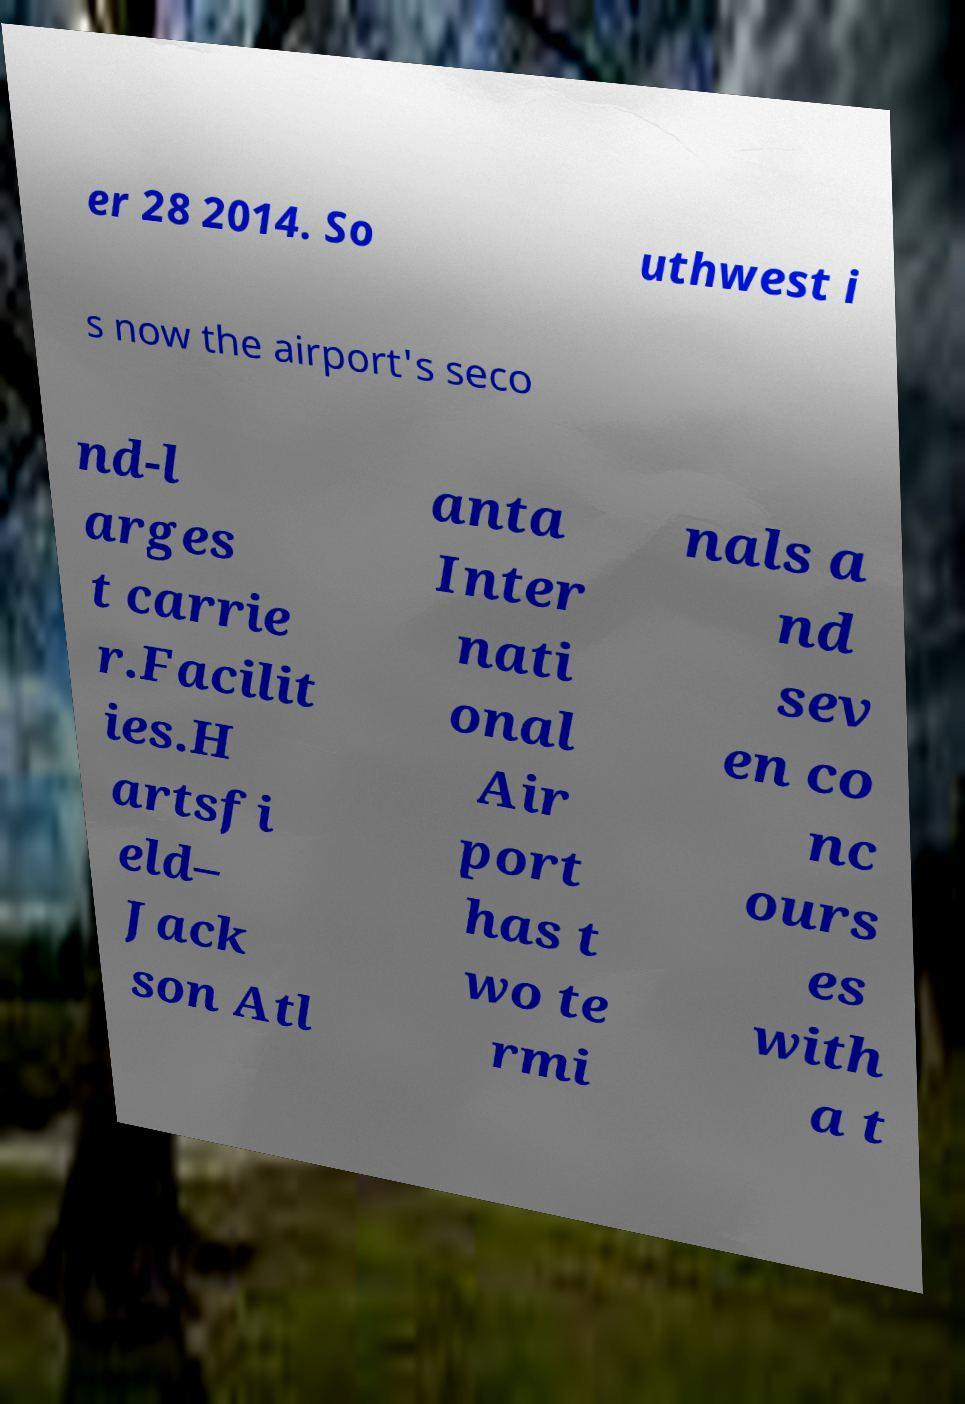Please identify and transcribe the text found in this image. er 28 2014. So uthwest i s now the airport's seco nd-l arges t carrie r.Facilit ies.H artsfi eld– Jack son Atl anta Inter nati onal Air port has t wo te rmi nals a nd sev en co nc ours es with a t 